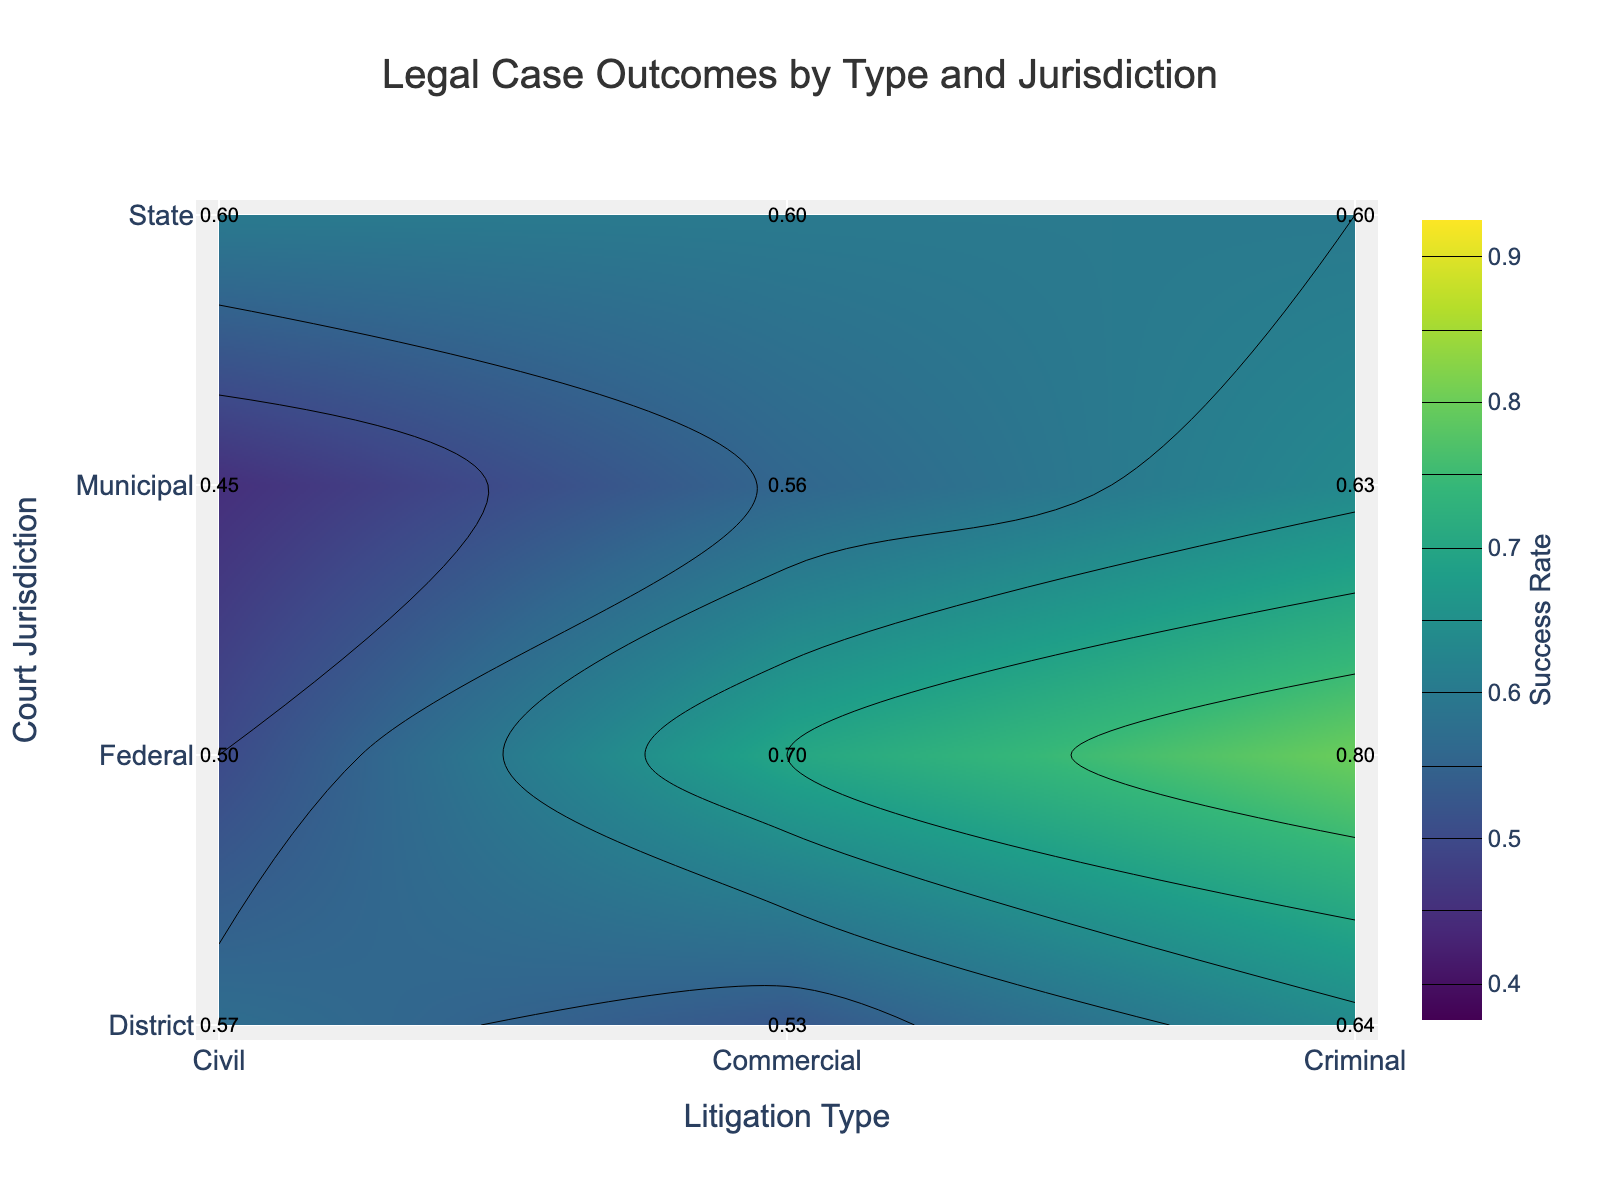what is the title of the plot? The title of the plot is located at the top center and clearly states the main subject.
Answer: Legal Case Outcomes by Type and Jurisdiction What is the success rate for criminal cases in federal court? Locate the intersection of "Federal" on the y-axis and "Criminal" on the x-axis, and read the success rate value annotated near this point.
Answer: 0.80 Which court jurisdiction has the highest success rate for civil cases? Compare the annotated success rates under the "Civil" litigation type across all court jurisdictions.
Answer: State What is the average success rate for commercial cases? Locate the success rates annotated next to the "Commercial" litigation type across all jurisdictions, then calculate the average: (0.7 + 0.60 + 0.53 + 0.56) / 4.
Answer: 0.60 Between state and municipal jurisdictions, which one has higher success rates for civil litigations, and by how much? Compare the annotated success rates for "Civil" litigation between "State" and "Municipal" court jurisdictions and subtract the smaller from the larger.
Answer: State by 0.35 What is the color used to represent a success rate of 0.75? Look at the color gradient on the contour plot or the color bar on the right side, which shows the color representation for different success rates and match it with 0.75.
Answer: Green Which court jurisdiction has the lowest success rate for criminal cases? Compare the annotated success rates under the "Criminal" litigation type across all court jurisdictions and identify the lowest value.
Answer: Municipal For commercial cases, which jurisdiction has a success rate closest to 0.58? Look at the annotated success rates under the "Commercial" litigation type and find the one closest to 0.58.
Answer: Municipal What is the success rate range displayed in the color bar? Look at the start and end values labeled on the color bar on the right side of the plot.
Answer: 0.4 to 0.9 